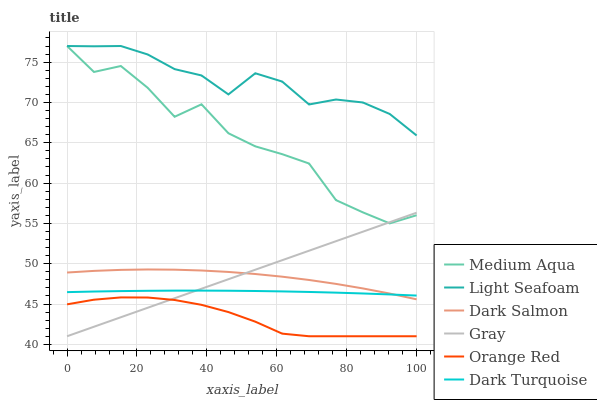Does Orange Red have the minimum area under the curve?
Answer yes or no. Yes. Does Light Seafoam have the maximum area under the curve?
Answer yes or no. Yes. Does Dark Turquoise have the minimum area under the curve?
Answer yes or no. No. Does Dark Turquoise have the maximum area under the curve?
Answer yes or no. No. Is Gray the smoothest?
Answer yes or no. Yes. Is Medium Aqua the roughest?
Answer yes or no. Yes. Is Dark Turquoise the smoothest?
Answer yes or no. No. Is Dark Turquoise the roughest?
Answer yes or no. No. Does Gray have the lowest value?
Answer yes or no. Yes. Does Dark Turquoise have the lowest value?
Answer yes or no. No. Does Light Seafoam have the highest value?
Answer yes or no. Yes. Does Dark Turquoise have the highest value?
Answer yes or no. No. Is Dark Turquoise less than Light Seafoam?
Answer yes or no. Yes. Is Medium Aqua greater than Dark Salmon?
Answer yes or no. Yes. Does Dark Salmon intersect Gray?
Answer yes or no. Yes. Is Dark Salmon less than Gray?
Answer yes or no. No. Is Dark Salmon greater than Gray?
Answer yes or no. No. Does Dark Turquoise intersect Light Seafoam?
Answer yes or no. No. 